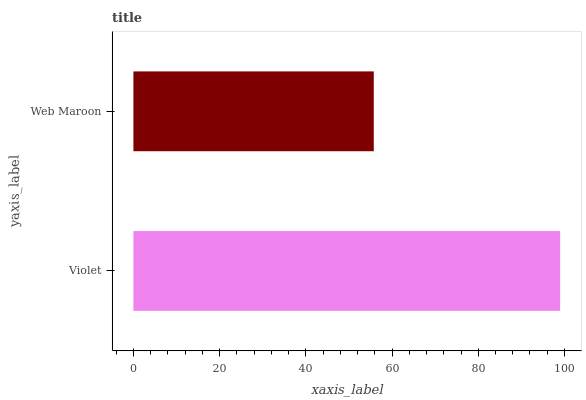Is Web Maroon the minimum?
Answer yes or no. Yes. Is Violet the maximum?
Answer yes or no. Yes. Is Web Maroon the maximum?
Answer yes or no. No. Is Violet greater than Web Maroon?
Answer yes or no. Yes. Is Web Maroon less than Violet?
Answer yes or no. Yes. Is Web Maroon greater than Violet?
Answer yes or no. No. Is Violet less than Web Maroon?
Answer yes or no. No. Is Violet the high median?
Answer yes or no. Yes. Is Web Maroon the low median?
Answer yes or no. Yes. Is Web Maroon the high median?
Answer yes or no. No. Is Violet the low median?
Answer yes or no. No. 